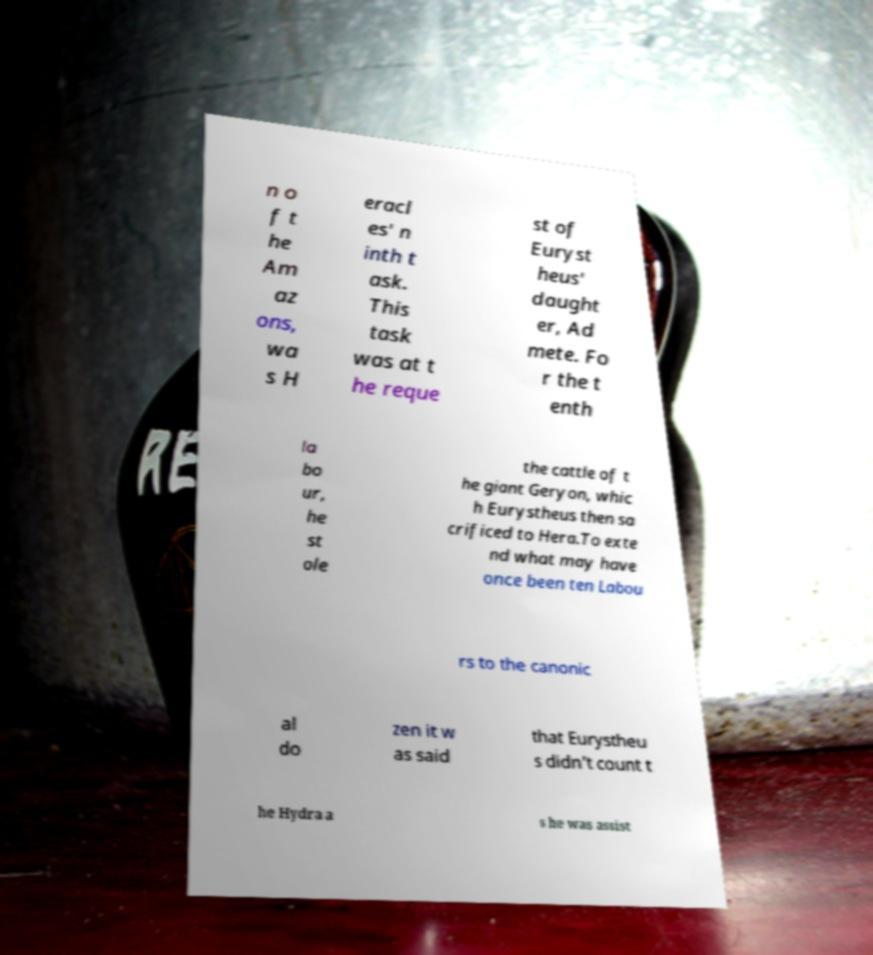Could you extract and type out the text from this image? n o f t he Am az ons, wa s H eracl es' n inth t ask. This task was at t he reque st of Euryst heus' daught er, Ad mete. Fo r the t enth la bo ur, he st ole the cattle of t he giant Geryon, whic h Eurystheus then sa crificed to Hera.To exte nd what may have once been ten Labou rs to the canonic al do zen it w as said that Eurystheu s didn't count t he Hydra a s he was assist 